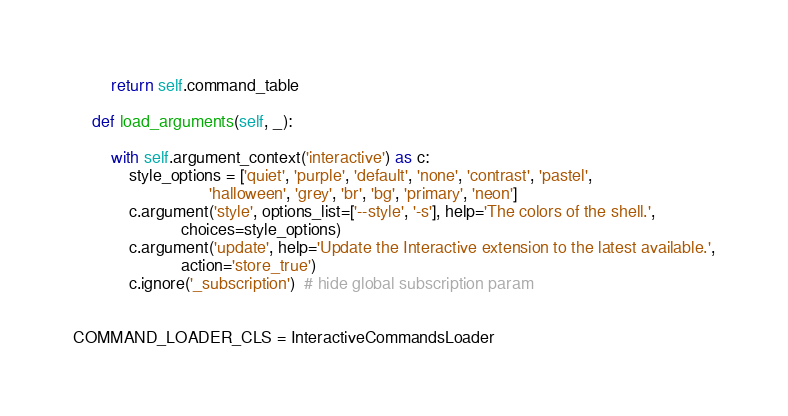<code> <loc_0><loc_0><loc_500><loc_500><_Python_>        return self.command_table

    def load_arguments(self, _):

        with self.argument_context('interactive') as c:
            style_options = ['quiet', 'purple', 'default', 'none', 'contrast', 'pastel',
                             'halloween', 'grey', 'br', 'bg', 'primary', 'neon']
            c.argument('style', options_list=['--style', '-s'], help='The colors of the shell.',
                       choices=style_options)
            c.argument('update', help='Update the Interactive extension to the latest available.',
                       action='store_true')
            c.ignore('_subscription')  # hide global subscription param


COMMAND_LOADER_CLS = InteractiveCommandsLoader
</code> 